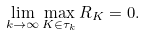Convert formula to latex. <formula><loc_0><loc_0><loc_500><loc_500>\lim _ { k \to \infty } \max _ { K \in \tau _ { k } } R _ { K } = 0 .</formula> 